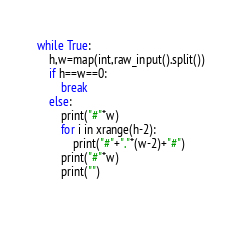Convert code to text. <code><loc_0><loc_0><loc_500><loc_500><_Python_>while True:
    h,w=map(int,raw_input().split())
    if h==w==0:
        break
    else:
        print("#"*w)
        for i in xrange(h-2):
            print("#"+"."*(w-2)+"#")
        print("#"*w)
        print("")
        </code> 